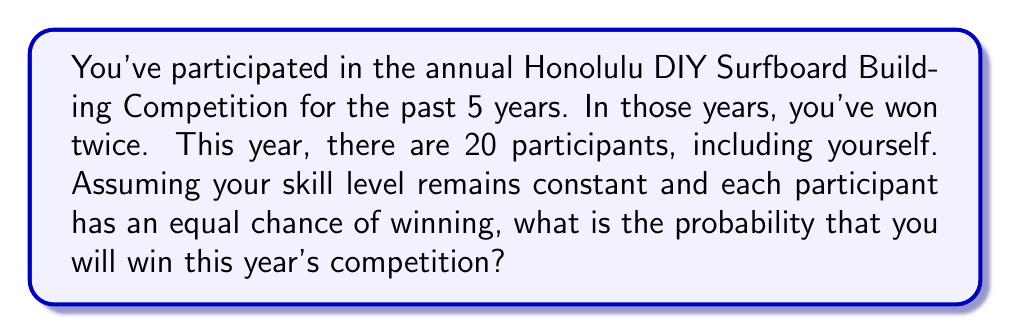Provide a solution to this math problem. Let's approach this step-by-step using the given information and probability concepts:

1) First, we need to calculate your success rate based on previous results:
   - You've participated 5 times and won twice
   - Your success rate = $\frac{\text{Number of wins}}{\text{Number of participations}} = \frac{2}{5} = 0.4$ or 40%

2) Now, we need to consider if this success rate is applicable to the current competition:
   - The question states that we should assume your skill level remains constant
   - It also states that each participant has an equal chance of winning

3) Given these assumptions, we can't use your personal success rate. Instead, we need to consider the probability based on the number of participants:
   - There are 20 participants this year
   - If each participant has an equal chance, the probability of any one person winning is:
     $P(\text{winning}) = \frac{1}{\text{Number of participants}} = \frac{1}{20} = 0.05$ or 5%

4) Therefore, despite your previous success rate of 40%, in this year's competition with 20 equal participants, your probability of winning is 5%.

This problem illustrates how historical data (your previous wins) may not always be applicable when conditions change (number of participants) and when we're given specific assumptions about equal chances.
Answer: $\frac{1}{20}$ or 0.05 or 5% 